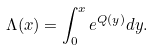<formula> <loc_0><loc_0><loc_500><loc_500>\Lambda ( x ) = \int _ { 0 } ^ { x } e ^ { Q ( y ) } d y .</formula> 